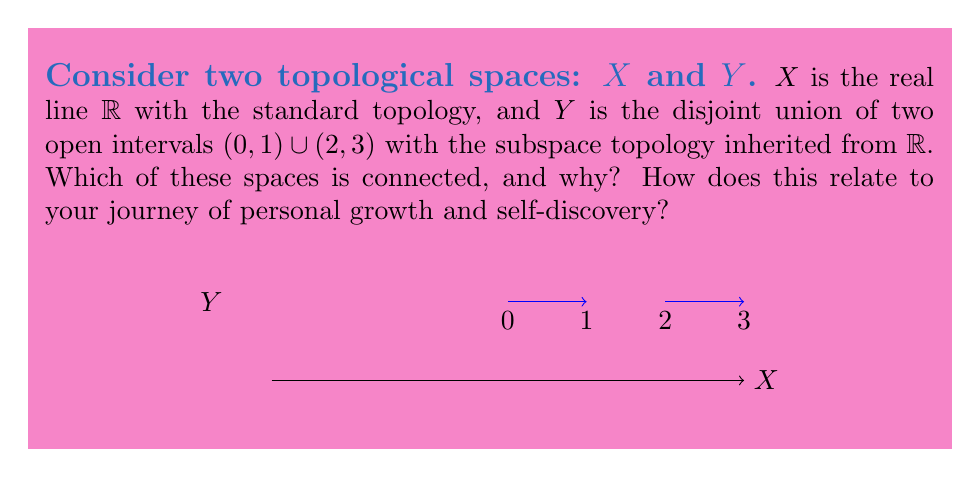Solve this math problem. Let's approach this step-by-step:

1) First, recall the definition of connectedness: A topological space is connected if it cannot be written as the union of two disjoint non-empty open sets.

2) For $X$ (the real line $\mathbb{R}$):
   - $\mathbb{R}$ is connected. This is because any two non-empty open sets in $\mathbb{R}$ must intersect.
   - If we try to separate $\mathbb{R}$ into two disjoint open sets, say $(-\infty, a)$ and $(a,\infty)$, we always miss the point $a$.

3) For $Y$ ($(0,1) \cup (2,3)$):
   - $Y$ is not connected. We can write it as the union of two disjoint non-empty open sets: $(0,1)$ and $(2,3)$.
   - These are open in the subspace topology and they don't intersect.

4) Relating to personal growth:
   - $X$ represents a continuous journey, where every point is connected to every other point, symbolizing how all our experiences are interconnected.
   - $Y$ represents a fragmented experience, with a gap between two phases of life. This could symbolize a major life change or a period of personal transformation.

5) The concept of connectedness in topology can be seen as a metaphor for the continuity and coherence of our personal narratives. A connected space like $X$ represents a life where all experiences flow into each other, while a disconnected space like $Y$ might represent a life with distinct, separate phases.

6) Understanding both connected and disconnected spaces can help us appreciate the value of both continuous growth and transformative leaps in our personal development.
Answer: $X$ is connected, $Y$ is disconnected. 